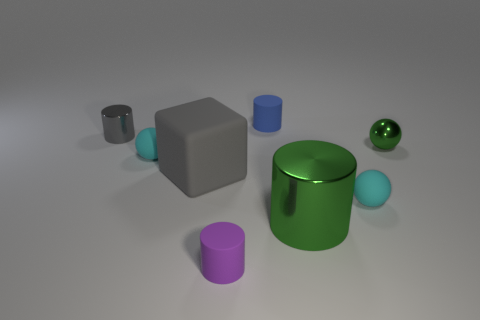Add 1 metallic things. How many objects exist? 9 Subtract all tiny shiny balls. How many balls are left? 2 Subtract all green cylinders. How many cyan spheres are left? 2 Subtract all purple cylinders. How many cylinders are left? 3 Subtract all balls. How many objects are left? 5 Subtract all small gray metallic cylinders. Subtract all cylinders. How many objects are left? 3 Add 5 small gray metallic cylinders. How many small gray metallic cylinders are left? 6 Add 7 small rubber cubes. How many small rubber cubes exist? 7 Subtract 1 gray blocks. How many objects are left? 7 Subtract all brown cubes. Subtract all purple cylinders. How many cubes are left? 1 